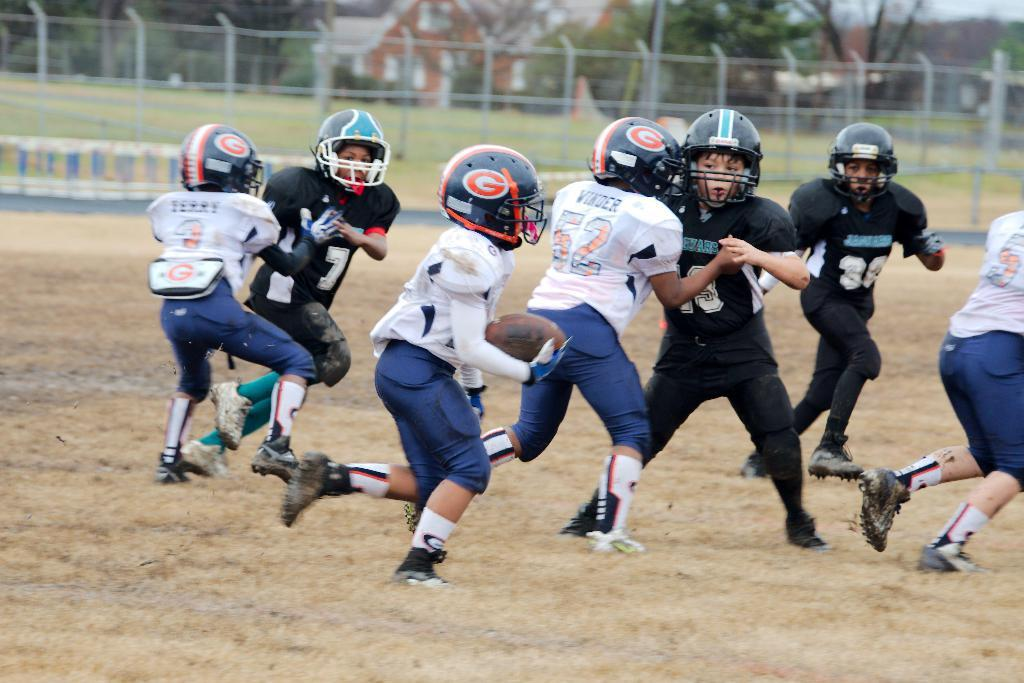What is happening in the center of the image? There is a group of people in the center of the image, and they are playing. What can be seen in the background of the image? There are houses, trees, and a net in the background of the image. Are there any ghosts visible in the image? There are no ghosts present in the image. What is the group of people's desire in the image? The image does not provide information about the group's desires, only that they are playing. 